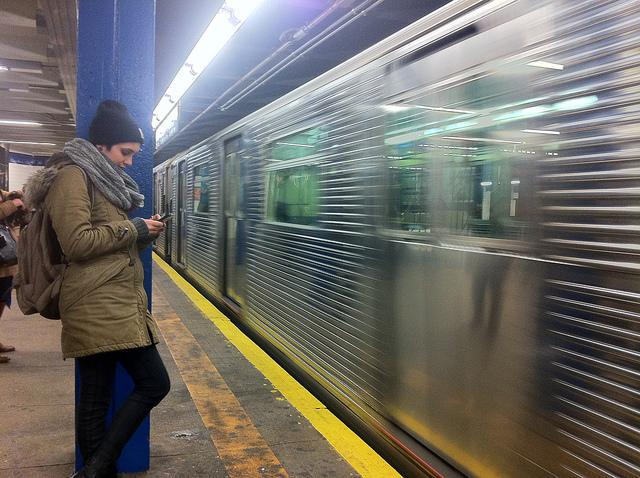The person next to the train looks like who? Please explain your reasoning. margaret qualley. The person wears a similar outfit the character. 